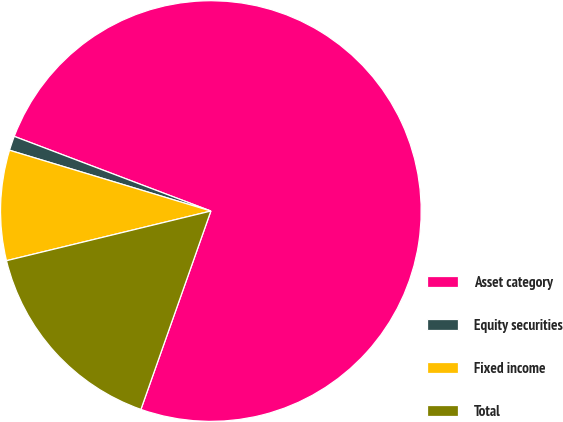<chart> <loc_0><loc_0><loc_500><loc_500><pie_chart><fcel>Asset category<fcel>Equity securities<fcel>Fixed income<fcel>Total<nl><fcel>74.61%<fcel>1.11%<fcel>8.46%<fcel>15.81%<nl></chart> 